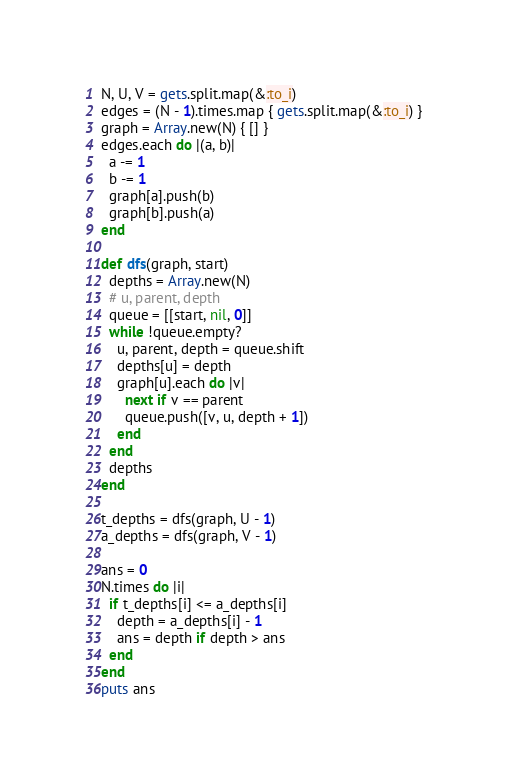<code> <loc_0><loc_0><loc_500><loc_500><_Ruby_>N, U, V = gets.split.map(&:to_i)
edges = (N - 1).times.map { gets.split.map(&:to_i) }
graph = Array.new(N) { [] }
edges.each do |(a, b)|
  a -= 1
  b -= 1
  graph[a].push(b)
  graph[b].push(a)
end

def dfs(graph, start)
  depths = Array.new(N)
  # u, parent, depth
  queue = [[start, nil, 0]]
  while !queue.empty?
    u, parent, depth = queue.shift
    depths[u] = depth
    graph[u].each do |v|
      next if v == parent
      queue.push([v, u, depth + 1])
    end
  end
  depths
end

t_depths = dfs(graph, U - 1)
a_depths = dfs(graph, V - 1)

ans = 0
N.times do |i|
  if t_depths[i] <= a_depths[i]
    depth = a_depths[i] - 1
    ans = depth if depth > ans
  end
end
puts ans
</code> 